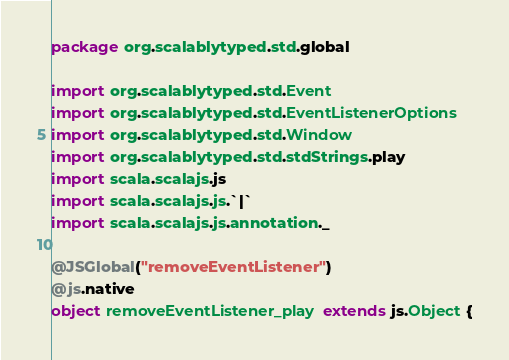Convert code to text. <code><loc_0><loc_0><loc_500><loc_500><_Scala_>package org.scalablytyped.std.global

import org.scalablytyped.std.Event
import org.scalablytyped.std.EventListenerOptions
import org.scalablytyped.std.Window
import org.scalablytyped.std.stdStrings.play
import scala.scalajs.js
import scala.scalajs.js.`|`
import scala.scalajs.js.annotation._

@JSGlobal("removeEventListener")
@js.native
object removeEventListener_play extends js.Object {</code> 